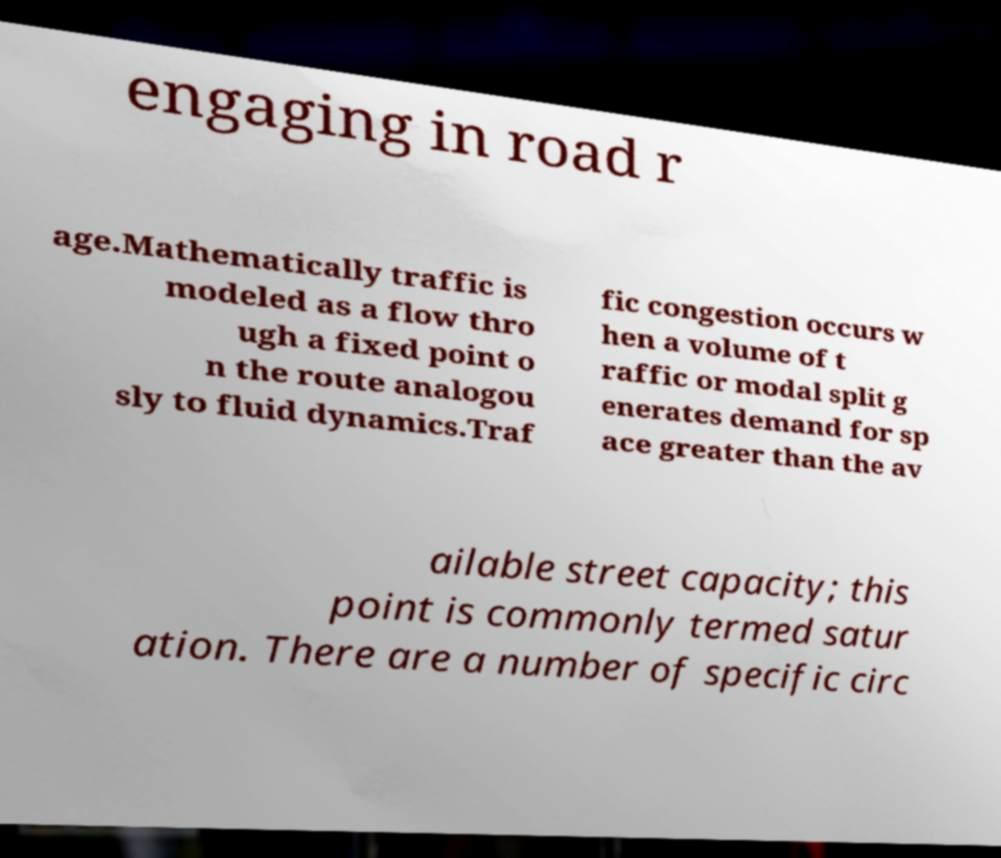Can you read and provide the text displayed in the image?This photo seems to have some interesting text. Can you extract and type it out for me? engaging in road r age.Mathematically traffic is modeled as a flow thro ugh a fixed point o n the route analogou sly to fluid dynamics.Traf fic congestion occurs w hen a volume of t raffic or modal split g enerates demand for sp ace greater than the av ailable street capacity; this point is commonly termed satur ation. There are a number of specific circ 